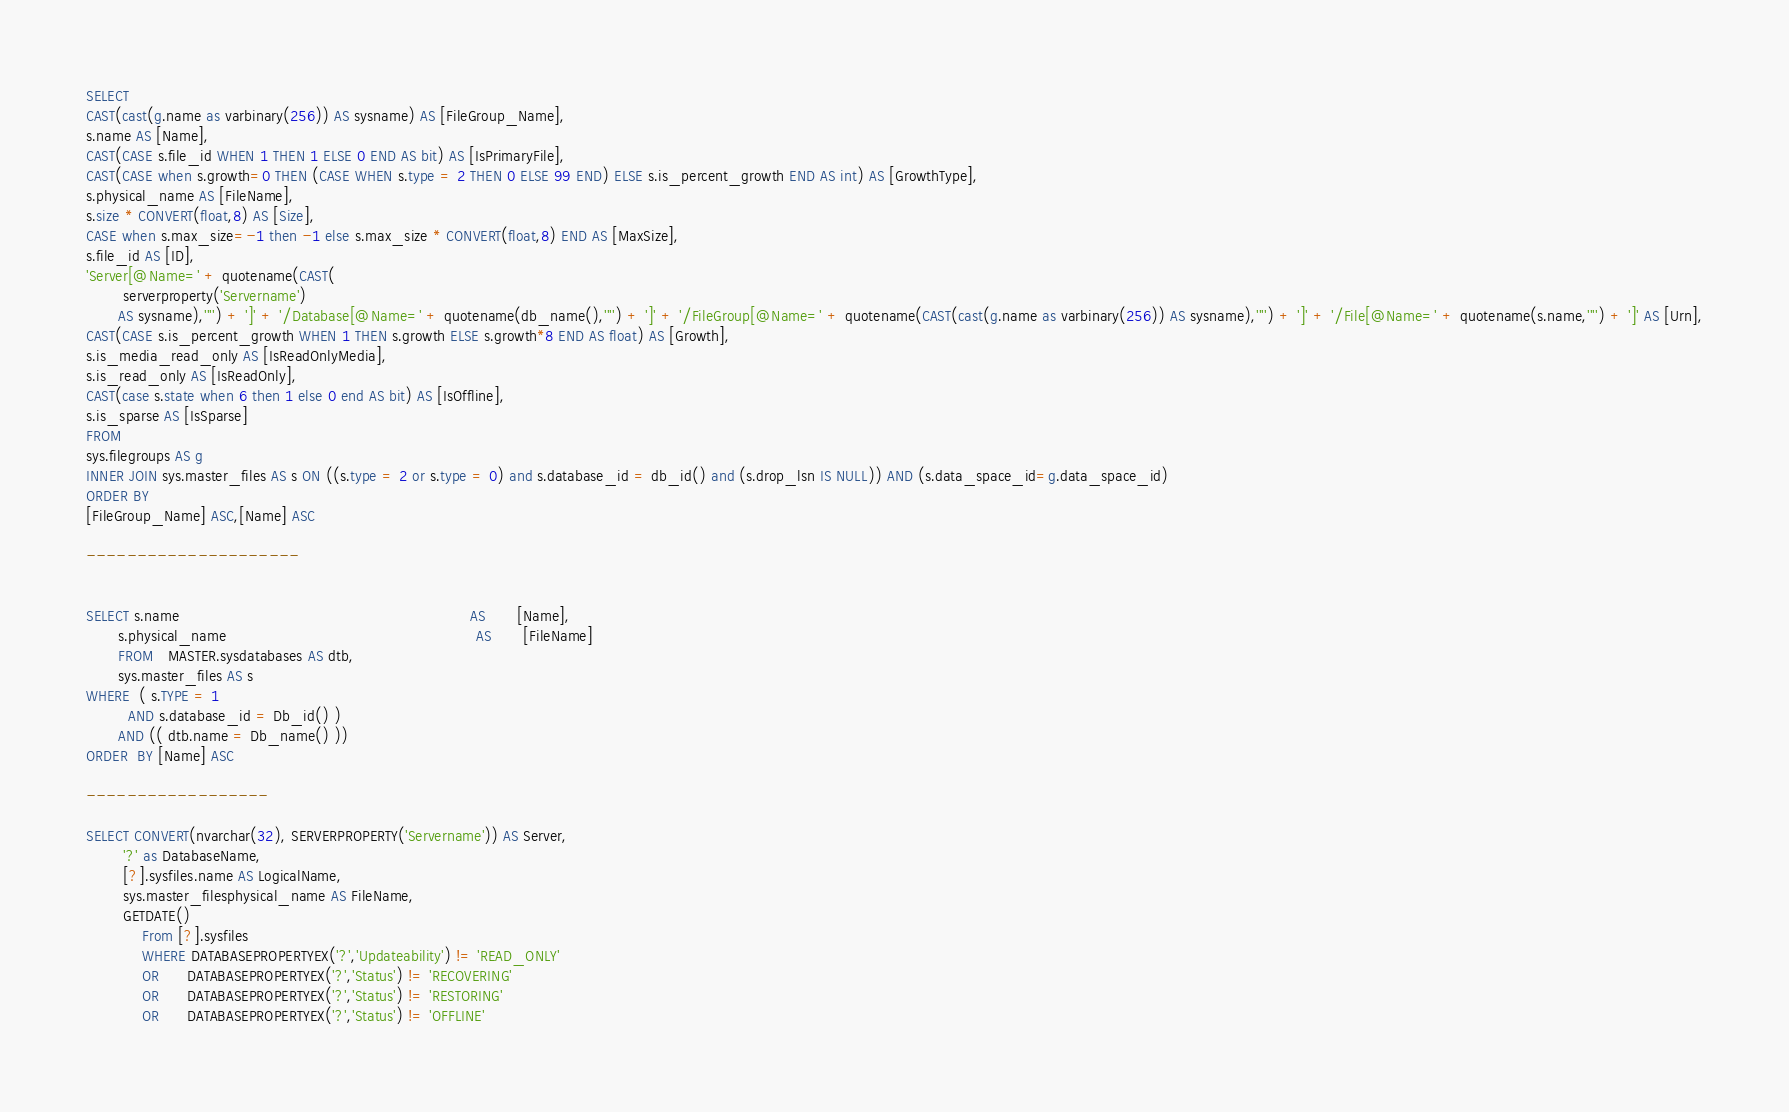Convert code to text. <code><loc_0><loc_0><loc_500><loc_500><_SQL_>SELECT
CAST(cast(g.name as varbinary(256)) AS sysname) AS [FileGroup_Name],
s.name AS [Name],
CAST(CASE s.file_id WHEN 1 THEN 1 ELSE 0 END AS bit) AS [IsPrimaryFile],
CAST(CASE when s.growth=0 THEN (CASE WHEN s.type = 2 THEN 0 ELSE 99 END) ELSE s.is_percent_growth END AS int) AS [GrowthType],
s.physical_name AS [FileName],
s.size * CONVERT(float,8) AS [Size],
CASE when s.max_size=-1 then -1 else s.max_size * CONVERT(float,8) END AS [MaxSize],
s.file_id AS [ID],
'Server[@Name=' + quotename(CAST(
        serverproperty('Servername')
       AS sysname),'''') + ']' + '/Database[@Name=' + quotename(db_name(),'''') + ']' + '/FileGroup[@Name=' + quotename(CAST(cast(g.name as varbinary(256)) AS sysname),'''') + ']' + '/File[@Name=' + quotename(s.name,'''') + ']' AS [Urn],
CAST(CASE s.is_percent_growth WHEN 1 THEN s.growth ELSE s.growth*8 END AS float) AS [Growth],
s.is_media_read_only AS [IsReadOnlyMedia],
s.is_read_only AS [IsReadOnly],
CAST(case s.state when 6 then 1 else 0 end AS bit) AS [IsOffline],
s.is_sparse AS [IsSparse]
FROM
sys.filegroups AS g
INNER JOIN sys.master_files AS s ON ((s.type = 2 or s.type = 0) and s.database_id = db_id() and (s.drop_lsn IS NULL)) AND (s.data_space_id=g.data_space_id)
ORDER BY
[FileGroup_Name] ASC,[Name] ASC

---------------------


SELECT s.name                                                               AS       [Name],
       s.physical_name                                                      AS       [FileName]
       FROM   MASTER.sysdatabases AS dtb,
       sys.master_files AS s
WHERE  ( s.TYPE = 1
         AND s.database_id = Db_id() )
       AND (( dtb.name = Db_name() ))
ORDER  BY [Name] ASC

------------------

SELECT CONVERT(nvarchar(32), SERVERPROPERTY('Servername')) AS Server,
		'?' as DatabaseName,
		[?].sysfiles.name AS LogicalName, 
		sys.master_filesphysical_name AS FileName,
		GETDATE()
			From [?].sysfiles
			WHERE DATABASEPROPERTYEX('?','Updateability') != 'READ_ONLY'
			OR	  DATABASEPROPERTYEX('?','Status') != 'RECOVERING'
			OR	  DATABASEPROPERTYEX('?','Status') != 'RESTORING'
			OR	  DATABASEPROPERTYEX('?','Status') != 'OFFLINE'
</code> 